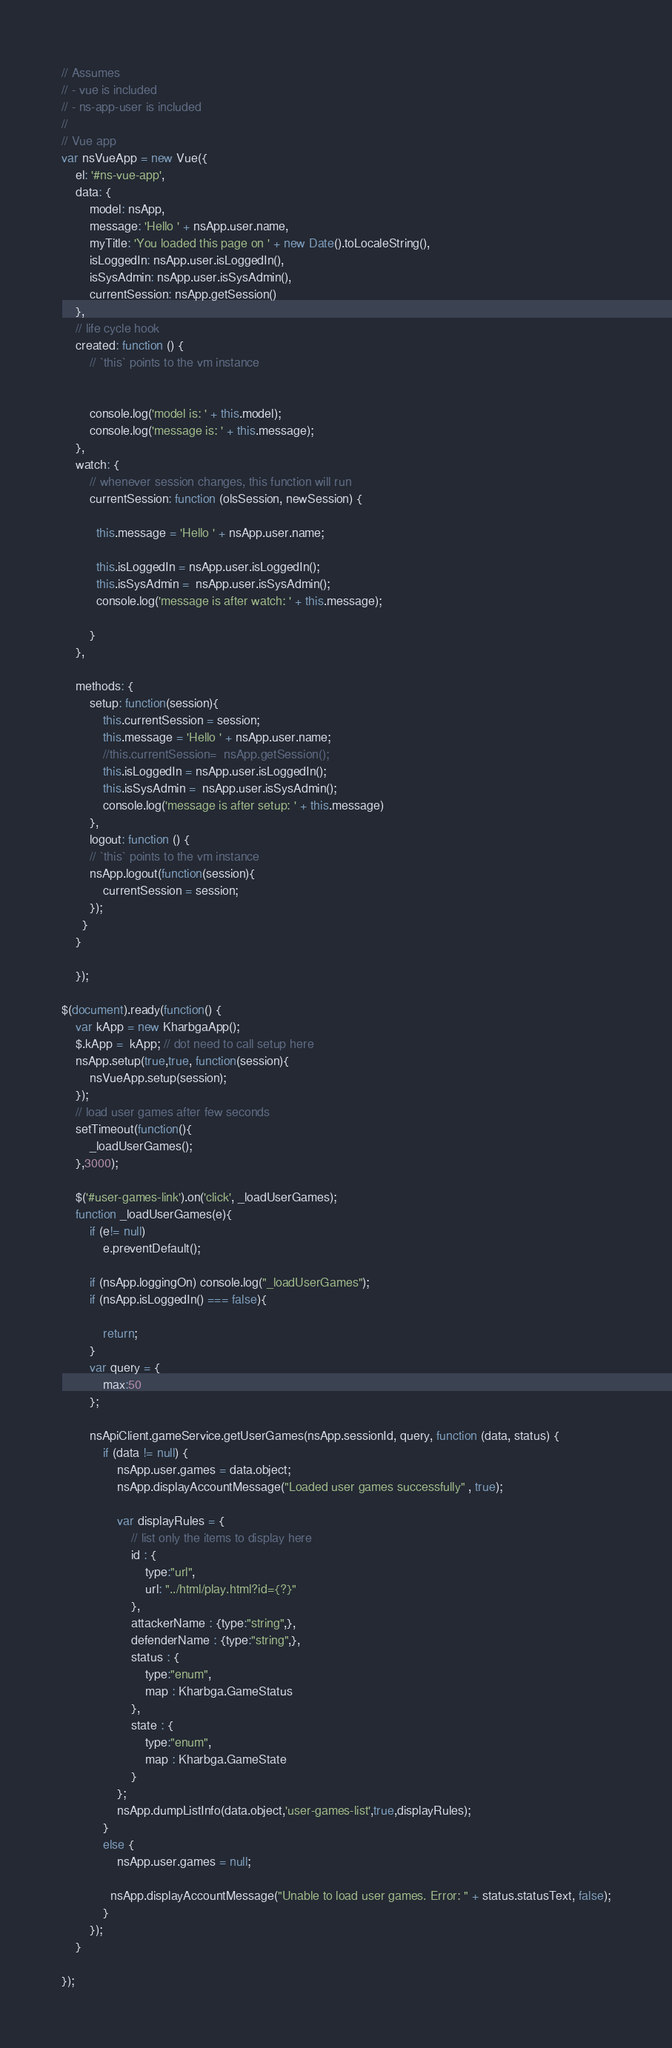<code> <loc_0><loc_0><loc_500><loc_500><_JavaScript_>// Assumes 
// - vue is included
// - ns-app-user is included
// 
// Vue app 
var nsVueApp = new Vue({
    el: '#ns-vue-app',
    data: {
        model: nsApp,
        message: 'Hello ' + nsApp.user.name, 
        myTitle: 'You loaded this page on ' + new Date().toLocaleString(),
        isLoggedIn: nsApp.user.isLoggedIn(),
        isSysAdmin: nsApp.user.isSysAdmin(),
        currentSession: nsApp.getSession()
    },
    // life cycle hook
    created: function () {
        // `this` points to the vm instance
       
     
        console.log('model is: ' + this.model);
        console.log('message is: ' + this.message);
    },
    watch: {
        // whenever session changes, this function will run
        currentSession: function (olsSession, newSession) {
          
          this.message = 'Hello ' + nsApp.user.name;
         
          this.isLoggedIn = nsApp.user.isLoggedIn();
          this.isSysAdmin =  nsApp.user.isSysAdmin();
          console.log('message is after watch: ' + this.message);
         
        }
    },

    methods: {
        setup: function(session){
            this.currentSession = session;          
            this.message = 'Hello ' + nsApp.user.name;
            //this.currentSession=  nsApp.getSession();
            this.isLoggedIn = nsApp.user.isLoggedIn();
            this.isSysAdmin =  nsApp.user.isSysAdmin();
            console.log('message is after setup: ' + this.message)
        },
        logout: function () {
        // `this` points to the vm instance
        nsApp.logout(function(session){
            currentSession = session;
        });
      }
    }
    
    });

$(document).ready(function() {
    var kApp = new KharbgaApp();
    $.kApp =  kApp; // dot need to call setup here
    nsApp.setup(true,true, function(session){
        nsVueApp.setup(session);
    });
    // load user games after few seconds
    setTimeout(function(){
        _loadUserGames();
    },3000);

    $('#user-games-link').on('click', _loadUserGames);
    function _loadUserGames(e){
        if (e!= null)
            e.preventDefault(); 

        if (nsApp.loggingOn) console.log("_loadUserGames");
        if (nsApp.isLoggedIn() === false){
            
            return;
        }
        var query = {
            max:50
        };

        nsApiClient.gameService.getUserGames(nsApp.sessionId, query, function (data, status) {
            if (data != null) {
                nsApp.user.games = data.object;
                nsApp.displayAccountMessage("Loaded user games successfully" , true);
      
                var displayRules = {
                    // list only the items to display here
                    id : {
                        type:"url",
                        url: "../html/play.html?id={?}"
                    }, 
                    attackerName : {type:"string",},
                    defenderName : {type:"string",},
                    status : {
                        type:"enum", 
                        map : Kharbga.GameStatus
                    },
                    state : {
                        type:"enum", 
                        map : Kharbga.GameState
                    }
                }; 
                nsApp.dumpListInfo(data.object,'user-games-list',true,displayRules);
            }
            else {
                nsApp.user.games = null;
              
              nsApp.displayAccountMessage("Unable to load user games. Error: " + status.statusText, false);
            }
        });
    }

});

</code> 